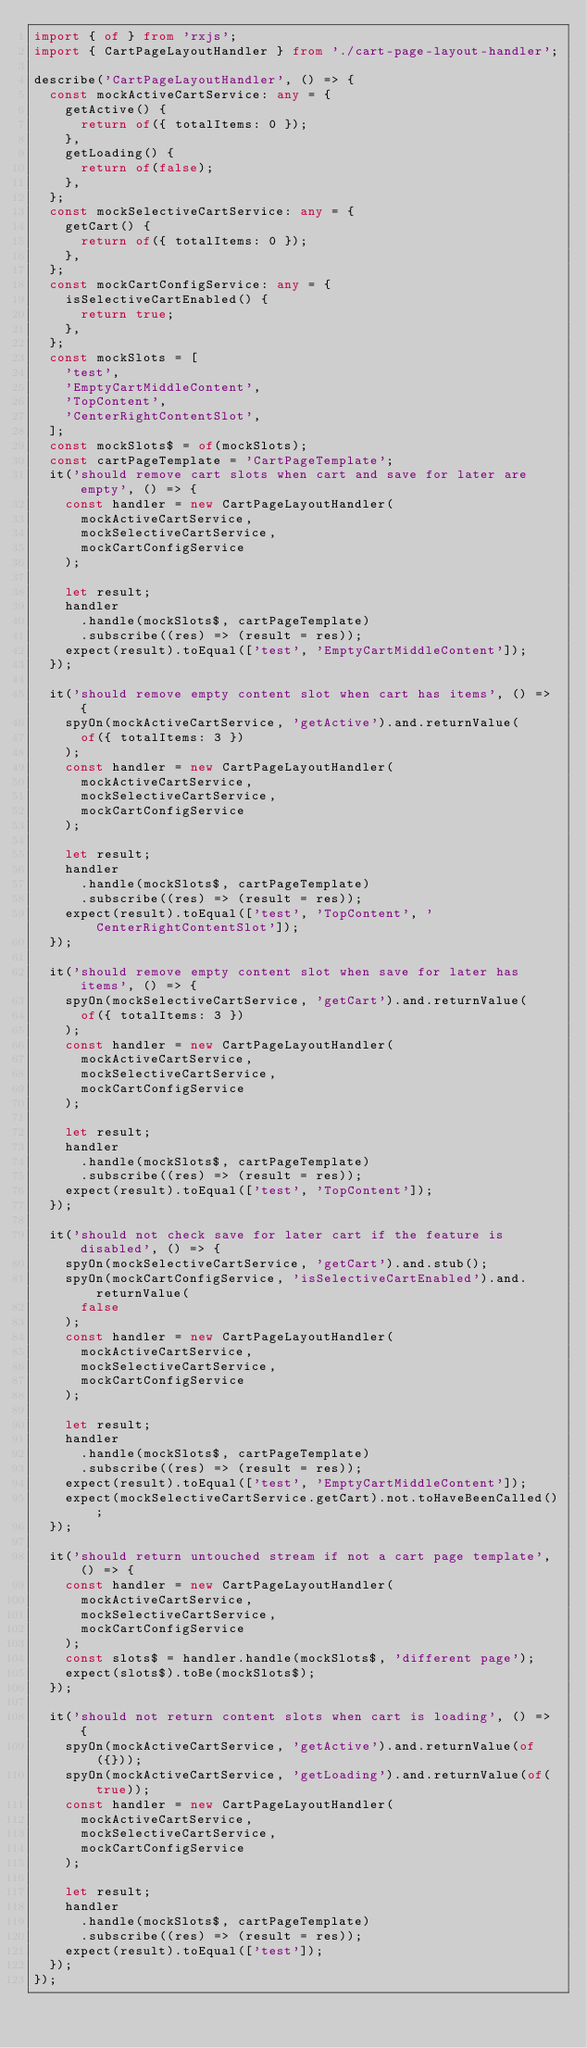Convert code to text. <code><loc_0><loc_0><loc_500><loc_500><_TypeScript_>import { of } from 'rxjs';
import { CartPageLayoutHandler } from './cart-page-layout-handler';

describe('CartPageLayoutHandler', () => {
  const mockActiveCartService: any = {
    getActive() {
      return of({ totalItems: 0 });
    },
    getLoading() {
      return of(false);
    },
  };
  const mockSelectiveCartService: any = {
    getCart() {
      return of({ totalItems: 0 });
    },
  };
  const mockCartConfigService: any = {
    isSelectiveCartEnabled() {
      return true;
    },
  };
  const mockSlots = [
    'test',
    'EmptyCartMiddleContent',
    'TopContent',
    'CenterRightContentSlot',
  ];
  const mockSlots$ = of(mockSlots);
  const cartPageTemplate = 'CartPageTemplate';
  it('should remove cart slots when cart and save for later are empty', () => {
    const handler = new CartPageLayoutHandler(
      mockActiveCartService,
      mockSelectiveCartService,
      mockCartConfigService
    );

    let result;
    handler
      .handle(mockSlots$, cartPageTemplate)
      .subscribe((res) => (result = res));
    expect(result).toEqual(['test', 'EmptyCartMiddleContent']);
  });

  it('should remove empty content slot when cart has items', () => {
    spyOn(mockActiveCartService, 'getActive').and.returnValue(
      of({ totalItems: 3 })
    );
    const handler = new CartPageLayoutHandler(
      mockActiveCartService,
      mockSelectiveCartService,
      mockCartConfigService
    );

    let result;
    handler
      .handle(mockSlots$, cartPageTemplate)
      .subscribe((res) => (result = res));
    expect(result).toEqual(['test', 'TopContent', 'CenterRightContentSlot']);
  });

  it('should remove empty content slot when save for later has items', () => {
    spyOn(mockSelectiveCartService, 'getCart').and.returnValue(
      of({ totalItems: 3 })
    );
    const handler = new CartPageLayoutHandler(
      mockActiveCartService,
      mockSelectiveCartService,
      mockCartConfigService
    );

    let result;
    handler
      .handle(mockSlots$, cartPageTemplate)
      .subscribe((res) => (result = res));
    expect(result).toEqual(['test', 'TopContent']);
  });

  it('should not check save for later cart if the feature is disabled', () => {
    spyOn(mockSelectiveCartService, 'getCart').and.stub();
    spyOn(mockCartConfigService, 'isSelectiveCartEnabled').and.returnValue(
      false
    );
    const handler = new CartPageLayoutHandler(
      mockActiveCartService,
      mockSelectiveCartService,
      mockCartConfigService
    );

    let result;
    handler
      .handle(mockSlots$, cartPageTemplate)
      .subscribe((res) => (result = res));
    expect(result).toEqual(['test', 'EmptyCartMiddleContent']);
    expect(mockSelectiveCartService.getCart).not.toHaveBeenCalled();
  });

  it('should return untouched stream if not a cart page template', () => {
    const handler = new CartPageLayoutHandler(
      mockActiveCartService,
      mockSelectiveCartService,
      mockCartConfigService
    );
    const slots$ = handler.handle(mockSlots$, 'different page');
    expect(slots$).toBe(mockSlots$);
  });

  it('should not return content slots when cart is loading', () => {
    spyOn(mockActiveCartService, 'getActive').and.returnValue(of({}));
    spyOn(mockActiveCartService, 'getLoading').and.returnValue(of(true));
    const handler = new CartPageLayoutHandler(
      mockActiveCartService,
      mockSelectiveCartService,
      mockCartConfigService
    );

    let result;
    handler
      .handle(mockSlots$, cartPageTemplate)
      .subscribe((res) => (result = res));
    expect(result).toEqual(['test']);
  });
});
</code> 